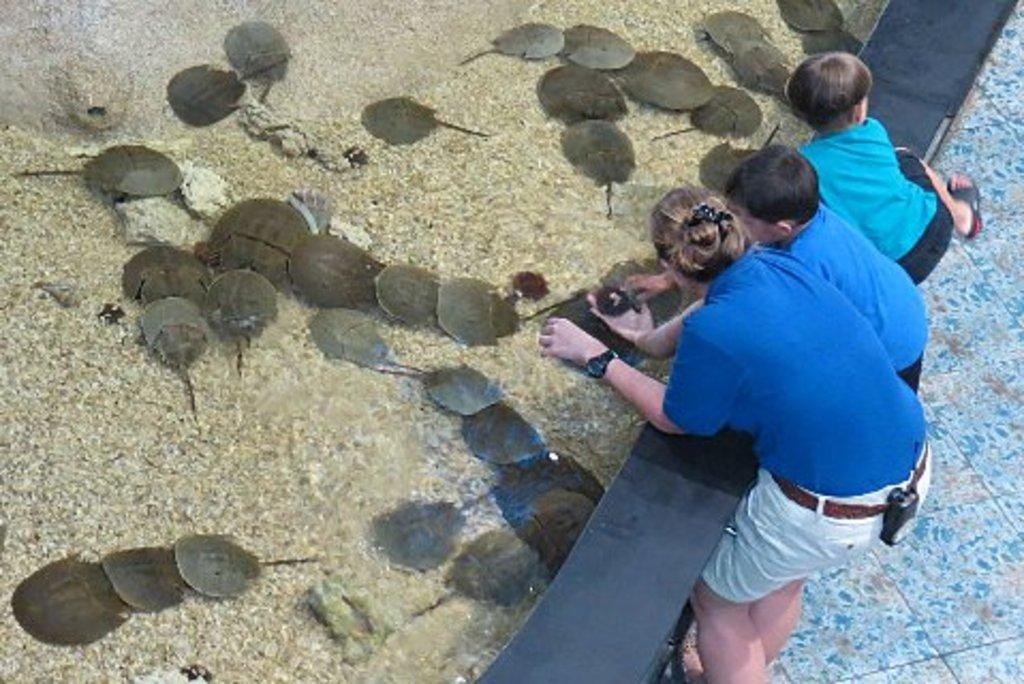What can be seen on the right side of the image? There are people on the right side of the image. What is present on the left side of the image? There are leaves on the left side of the image. Where are the people and leaves located? Both the people and leaves are placed on the land. What type of pleasure can be seen being experienced by the people in the image? There is no indication of pleasure being experienced by the people in the image, as their emotions or activities are not described in the provided facts. 